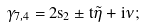<formula> <loc_0><loc_0><loc_500><loc_500>\gamma _ { 7 , 4 } = 2 s _ { 2 } \pm t \tilde { \eta } + i \nu ;</formula> 